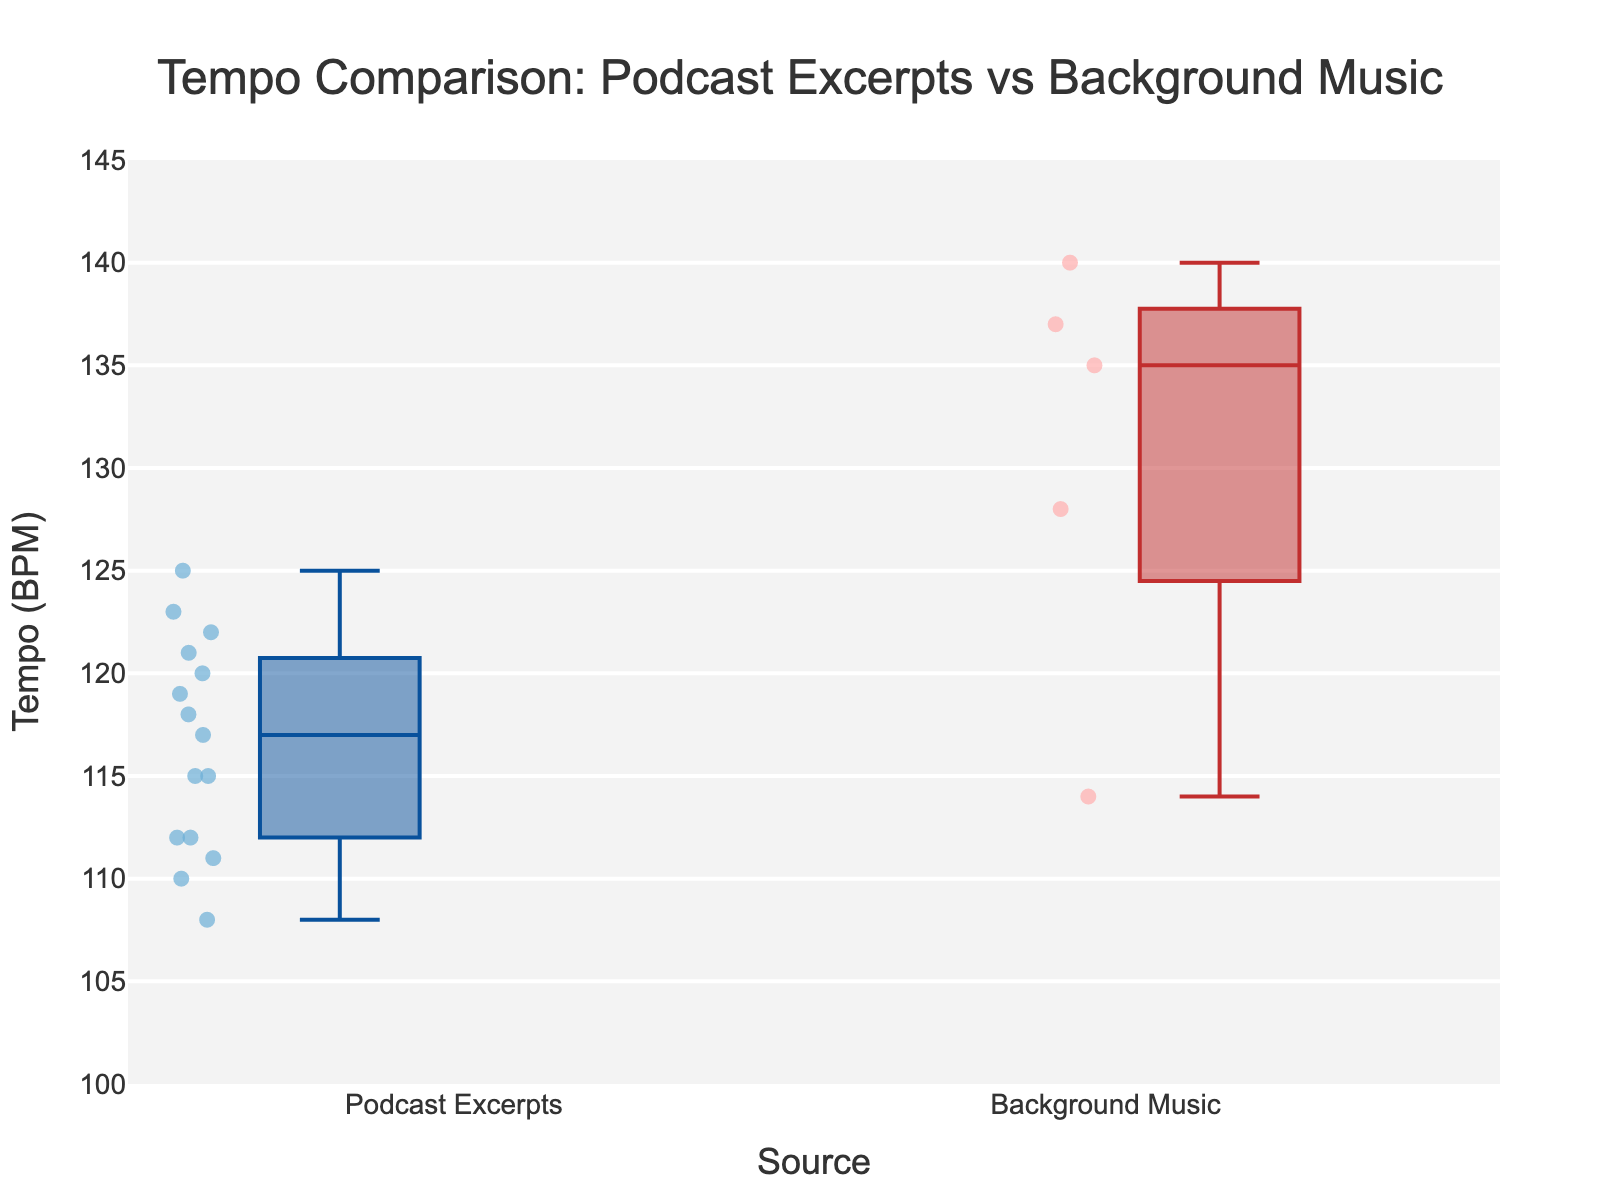What is the title of the plot? The title is displayed at the top of the plot within the layout, which reads "Tempo Comparison: Podcast Excerpts vs Background Music."
Answer: Tempo Comparison: Podcast Excerpts vs Background Music What is the y-axis labeled? The y-axis label is shown on the left-hand side of the plot and reads "Tempo (BPM)."
Answer: Tempo (BPM) Which group has the higher median tempo? Looking at the median lines within each box plot, the median line for Background Music is higher than for Podcast Excerpts.
Answer: Background Music What is the range of the y-axis? The range of the y-axis is specified by the y-axis settings and spans from 100 to 145.
Answer: 100 to 145 How many data points are there in the Background Music group? By counting the number of individual points (small dots) within the box plot for Background Music, we see there are 5 points.
Answer: 5 Which Podcast Source has the highest tempo in the Podcast Excerpts group and what is that tempo? By looking at the individual data points within the Podcast Excerpts box plot, the "Stuff You Should Know" has the highest tempo which aligns with the highest dot, marked at 123 BPM.
Answer: Stuff You Should Know, 123 BPM What is the interquartile range (IQR) for the Podcast Excerpts group? The IQR is the distance between the first quartile (Q1) and the third quartile (Q3) in the box plot. For Podcast Excerpts, Q3 appears to be around 120 and Q1 around 112. Thus, the IQR is 120 - 112 = 8.
Answer: 8 BPM Which group has more variability in tempo values? The variability is indicated by the length of the boxes (IQR) and the length of the whiskers (full range). The Background Music group has larger boxes and whiskers, indicating more variability.
Answer: Background Music What is the maximum tempo value for Background Music? The topmost point or whisker in the Background Music box plot aligns with 140 BPM.
Answer: 140 BPM What is the difference between the highest tempo in Podcast Excerpts and Background Music? The highest tempo in Podcast Excerpts is 123 BPM, and for Background Music, it is 140 BPM. Therefore, the difference is 140 - 123 = 17 BPM.
Answer: 17 BPM 